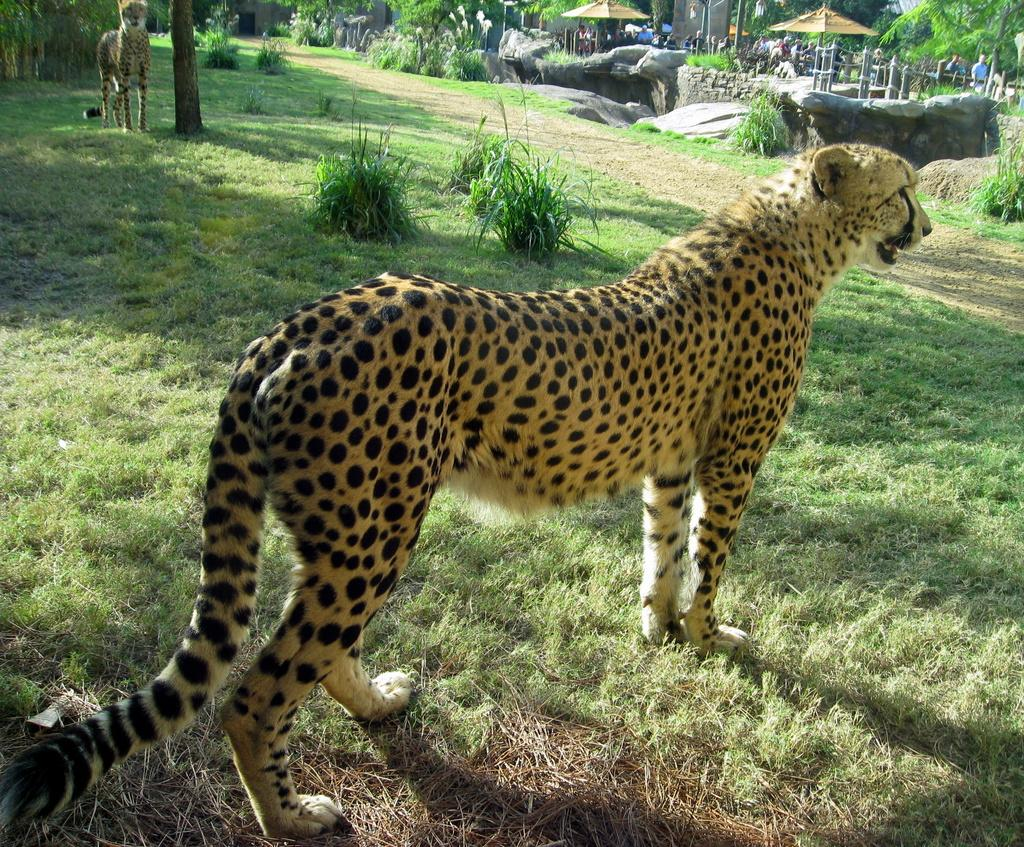How many leopards are in the image? There are 2 leopards in the image. What colors are the leopards? The leopards are orange and black in color. What type of vegetation is present in the image? There is green grass and plants in the image. What can be seen in the background of the image? There is fencing, trees, and people in the background of the image. What organization is responsible for maintaining the station in the image? There is no station present in the image, so it is not possible to determine which organization might be responsible for maintaining it. 